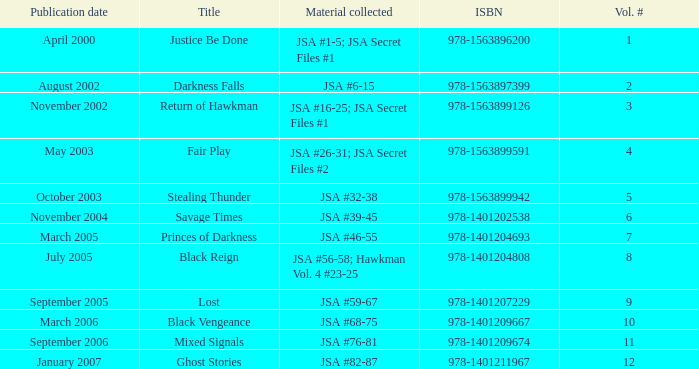How many Volume Numbers have the title of Darkness Falls? 2.0. 